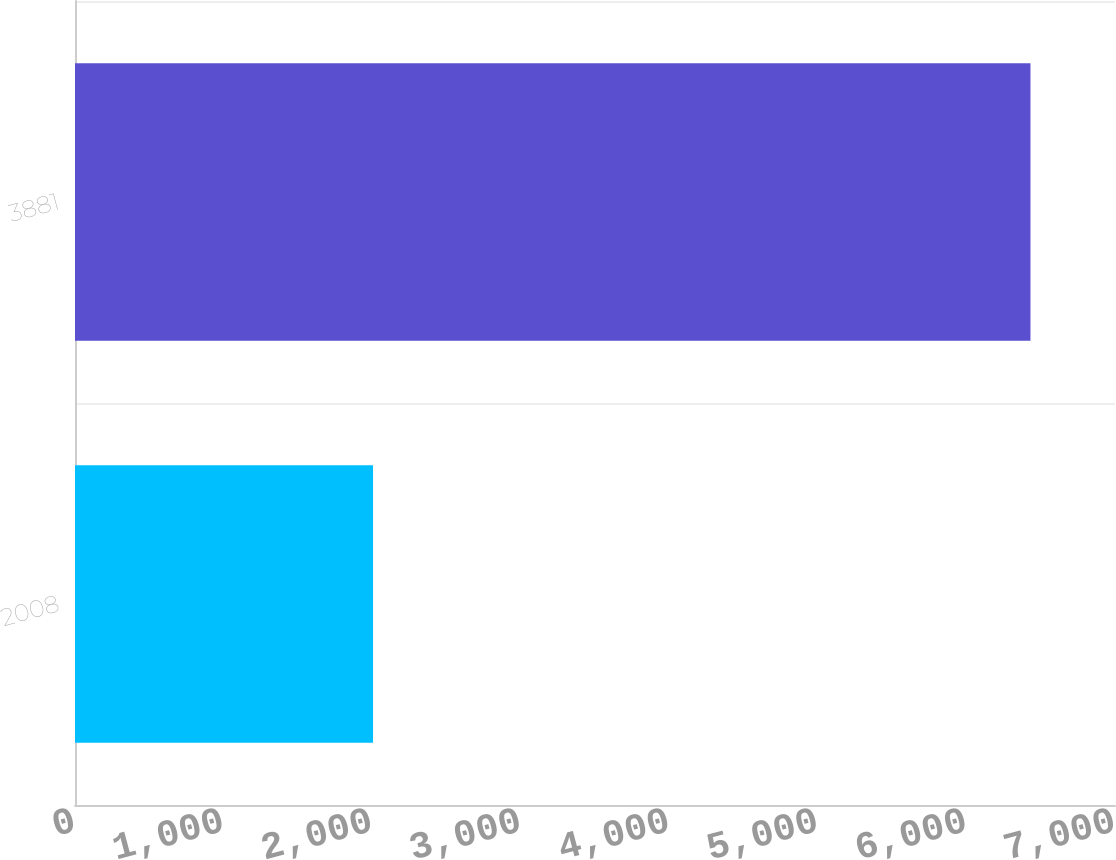<chart> <loc_0><loc_0><loc_500><loc_500><bar_chart><fcel>2008<fcel>3881<nl><fcel>2006<fcel>6431<nl></chart> 